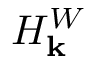Convert formula to latex. <formula><loc_0><loc_0><loc_500><loc_500>H _ { k } ^ { W }</formula> 